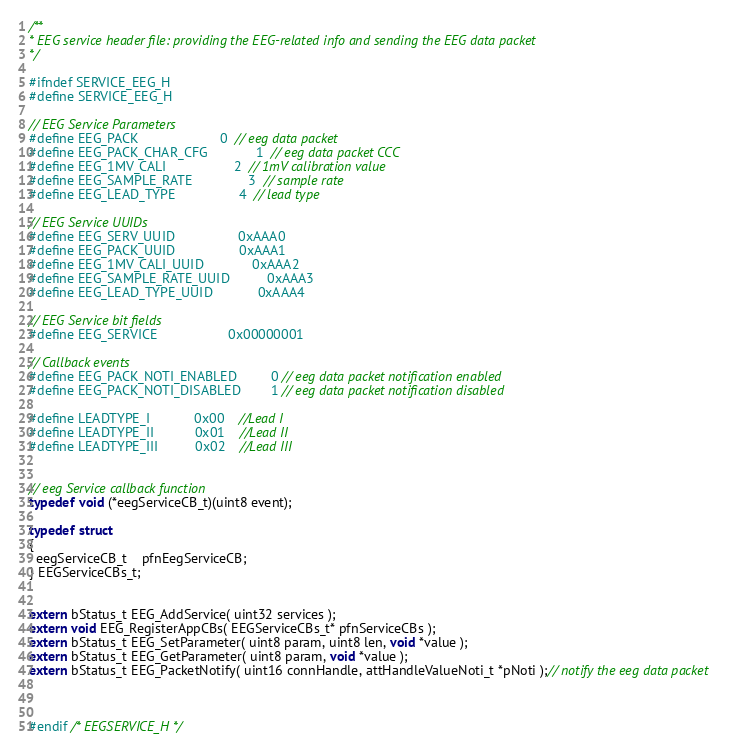<code> <loc_0><loc_0><loc_500><loc_500><_C_>/**
* EEG service header file: providing the EEG-related info and sending the EEG data packet
*/

#ifndef SERVICE_EEG_H
#define SERVICE_EEG_H

// EEG Service Parameters
#define EEG_PACK                      0  // eeg data packet
#define EEG_PACK_CHAR_CFG             1  // eeg data packet CCC
#define EEG_1MV_CALI                  2  // 1mV calibration value
#define EEG_SAMPLE_RATE               3  // sample rate
#define EEG_LEAD_TYPE                 4  // lead type

// EEG Service UUIDs
#define EEG_SERV_UUID                 0xAAA0
#define EEG_PACK_UUID                 0xAAA1
#define EEG_1MV_CALI_UUID             0xAAA2
#define EEG_SAMPLE_RATE_UUID          0xAAA3
#define EEG_LEAD_TYPE_UUID            0xAAA4

// EEG Service bit fields
#define EEG_SERVICE                   0x00000001

// Callback events
#define EEG_PACK_NOTI_ENABLED         0 // eeg data packet notification enabled
#define EEG_PACK_NOTI_DISABLED        1 // eeg data packet notification disabled

#define LEADTYPE_I            0x00    //Lead I
#define LEADTYPE_II           0x01    //Lead II
#define LEADTYPE_III          0x02    //Lead III


// eeg Service callback function
typedef void (*eegServiceCB_t)(uint8 event);

typedef struct
{
  eegServiceCB_t    pfnEegServiceCB;  
} EEGServiceCBs_t;


extern bStatus_t EEG_AddService( uint32 services );
extern void EEG_RegisterAppCBs( EEGServiceCBs_t* pfnServiceCBs );
extern bStatus_t EEG_SetParameter( uint8 param, uint8 len, void *value );
extern bStatus_t EEG_GetParameter( uint8 param, void *value );
extern bStatus_t EEG_PacketNotify( uint16 connHandle, attHandleValueNoti_t *pNoti );// notify the eeg data packet



#endif /* EEGSERVICE_H */
</code> 